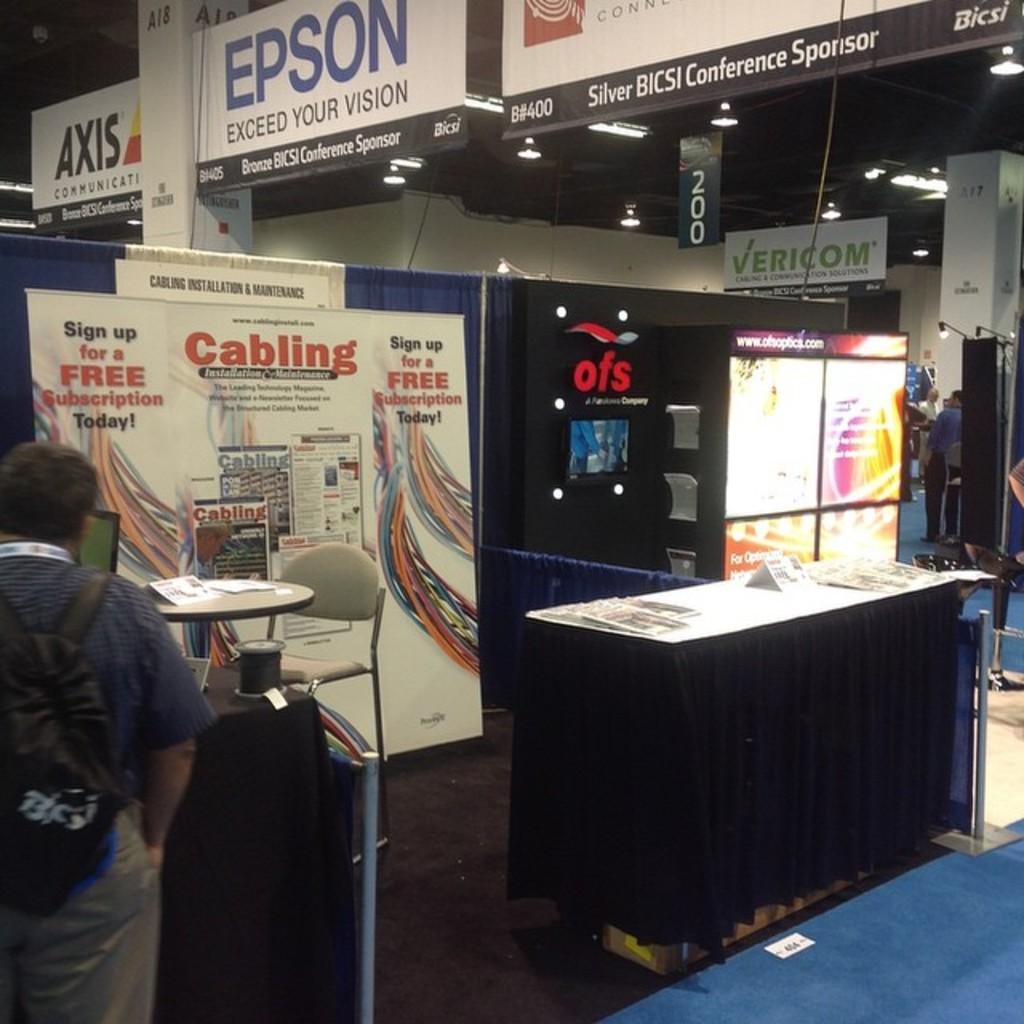Describe this image in one or two sentences. On the left we can see one man standing. And coming to the center we can see table,chairs,banners,sign board,pillar,wall,lights and few more persons were standing. 